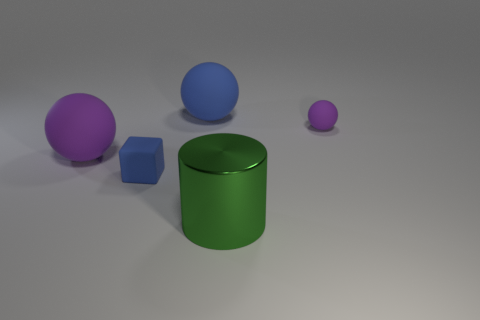There is a large green thing that is left of the purple object behind the purple matte object to the left of the small purple ball; what is it made of?
Make the answer very short. Metal. Does the tiny object that is in front of the tiny purple thing have the same material as the small purple sphere?
Make the answer very short. Yes. How many blue matte cubes are the same size as the blue ball?
Your answer should be compact. 0. Is the number of purple rubber objects to the right of the large metallic cylinder greater than the number of tiny blue blocks behind the small blue thing?
Provide a short and direct response. Yes. Is there another object of the same shape as the small blue rubber object?
Your response must be concise. No. How big is the blue matte sphere that is left of the purple thing that is on the right side of the big green shiny thing?
Give a very brief answer. Large. The large matte object on the right side of the purple object that is to the left of the object that is in front of the small blue block is what shape?
Give a very brief answer. Sphere. There is another purple ball that is made of the same material as the big purple ball; what size is it?
Your answer should be very brief. Small. Is the number of small blue rubber cubes greater than the number of large green blocks?
Ensure brevity in your answer.  Yes. What is the material of the blue sphere that is the same size as the green shiny cylinder?
Offer a very short reply. Rubber. 